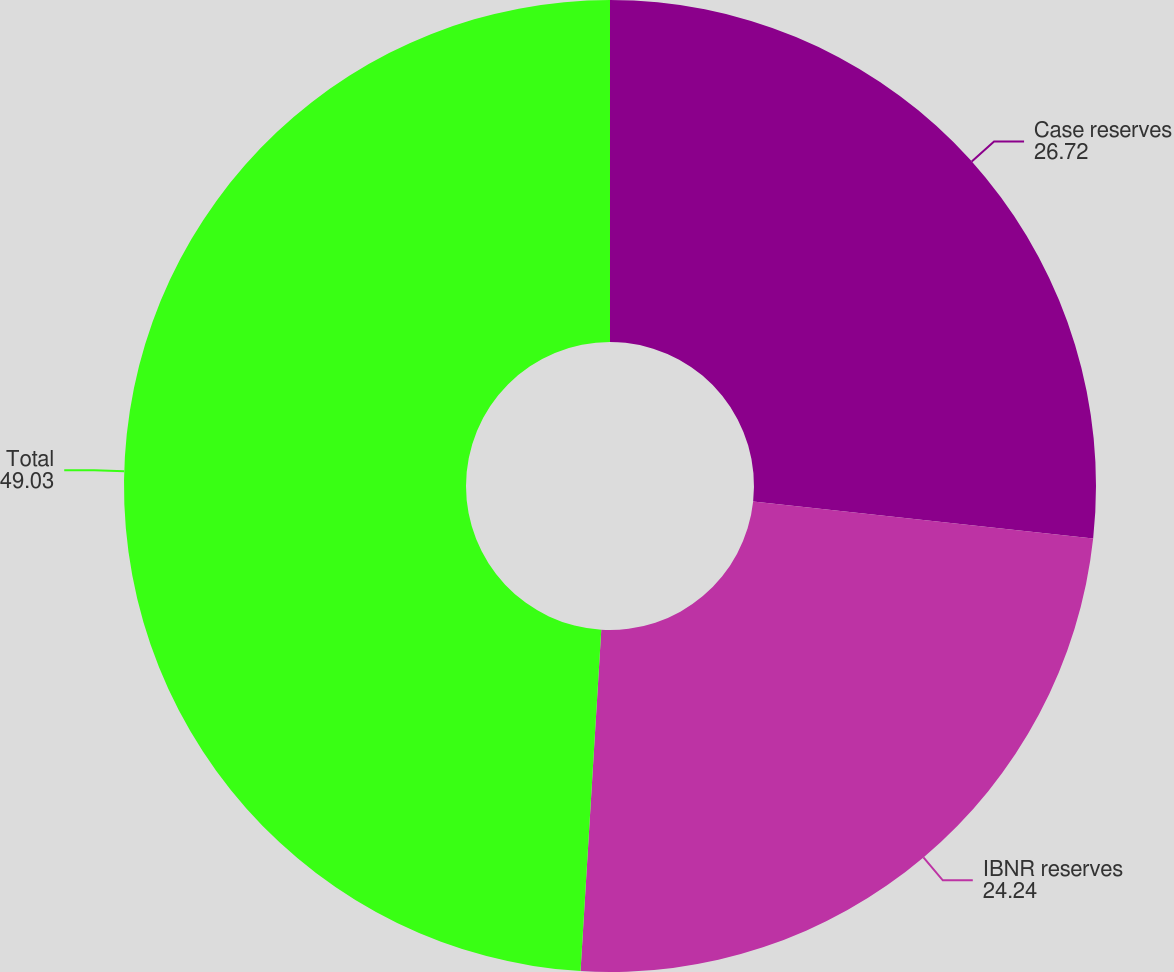Convert chart. <chart><loc_0><loc_0><loc_500><loc_500><pie_chart><fcel>Case reserves<fcel>IBNR reserves<fcel>Total<nl><fcel>26.72%<fcel>24.24%<fcel>49.03%<nl></chart> 